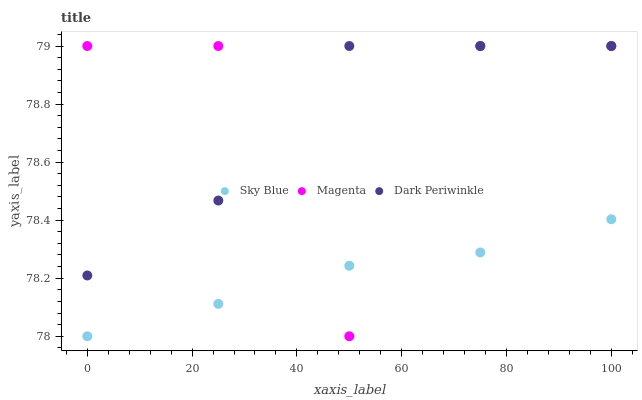Does Sky Blue have the minimum area under the curve?
Answer yes or no. Yes. Does Dark Periwinkle have the maximum area under the curve?
Answer yes or no. Yes. Does Magenta have the minimum area under the curve?
Answer yes or no. No. Does Magenta have the maximum area under the curve?
Answer yes or no. No. Is Sky Blue the smoothest?
Answer yes or no. Yes. Is Magenta the roughest?
Answer yes or no. Yes. Is Dark Periwinkle the smoothest?
Answer yes or no. No. Is Dark Periwinkle the roughest?
Answer yes or no. No. Does Sky Blue have the lowest value?
Answer yes or no. Yes. Does Magenta have the lowest value?
Answer yes or no. No. Does Dark Periwinkle have the highest value?
Answer yes or no. Yes. Is Sky Blue less than Dark Periwinkle?
Answer yes or no. Yes. Is Dark Periwinkle greater than Sky Blue?
Answer yes or no. Yes. Does Magenta intersect Dark Periwinkle?
Answer yes or no. Yes. Is Magenta less than Dark Periwinkle?
Answer yes or no. No. Is Magenta greater than Dark Periwinkle?
Answer yes or no. No. Does Sky Blue intersect Dark Periwinkle?
Answer yes or no. No. 